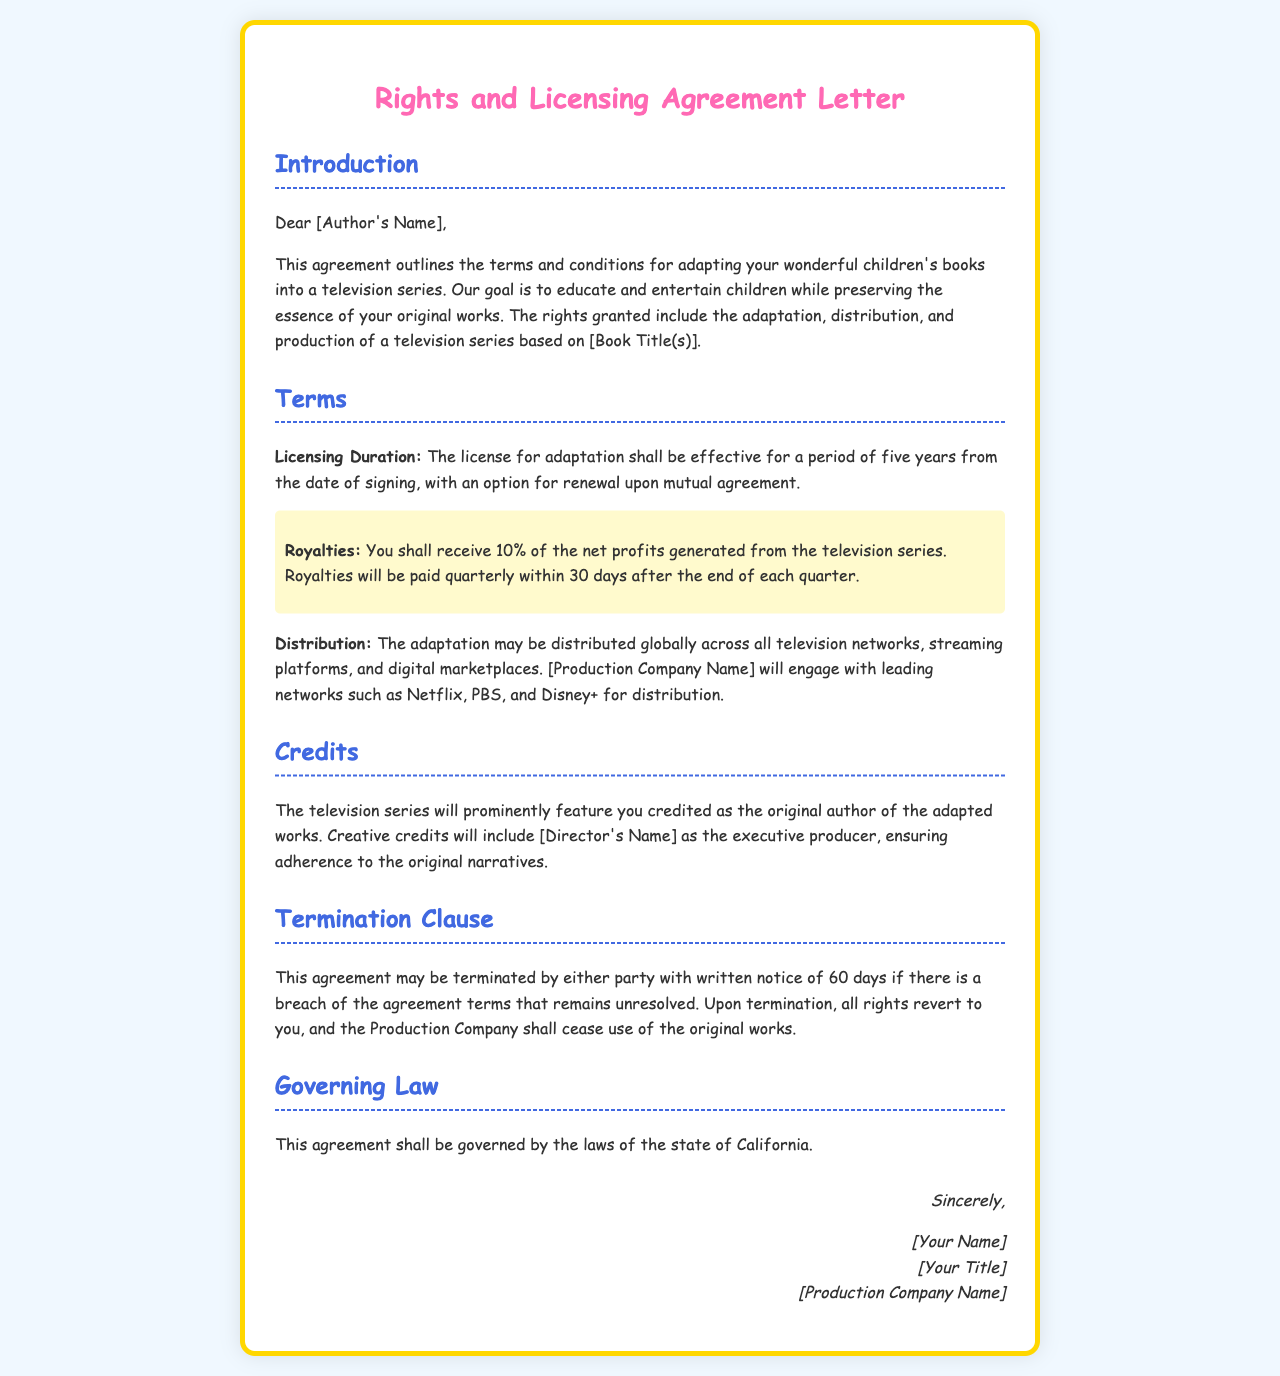What is the licensing duration? The licensing duration is specified in the terms of the agreement and indicates how long the license for adaptation is effective.
Answer: five years What percentage of net profits will the author receive as royalties? The document outlines the royalties section, specifically stating the percentage of net profits allocated to the author.
Answer: 10% Who will be credited as the original author? The credits section specifies who will be recognized as the original creator of the adapted works in the television series.
Answer: you Which production company is mentioned in the agreement? The introduction gives the name of the production company responsible for the adaptation and distribution of the series.
Answer: [Production Company Name] What is the notice period for termination of the agreement? The termination clause describes how much notice is required for either party to terminate the agreement.
Answer: 60 days What law governs this agreement? The governing law section names the jurisdiction that regulates the terms of the agreement.
Answer: California Who is noted as the executive producer in the credits? The document indicates a specific person associated with the creative credits, specifically the role of executive producer in the adaptation.
Answer: [Director's Name] What will happen to the rights upon termination of the agreement? The termination clause covers the reversion of rights and stipulates what occurs once the agreement is concluded.
Answer: revert to you 